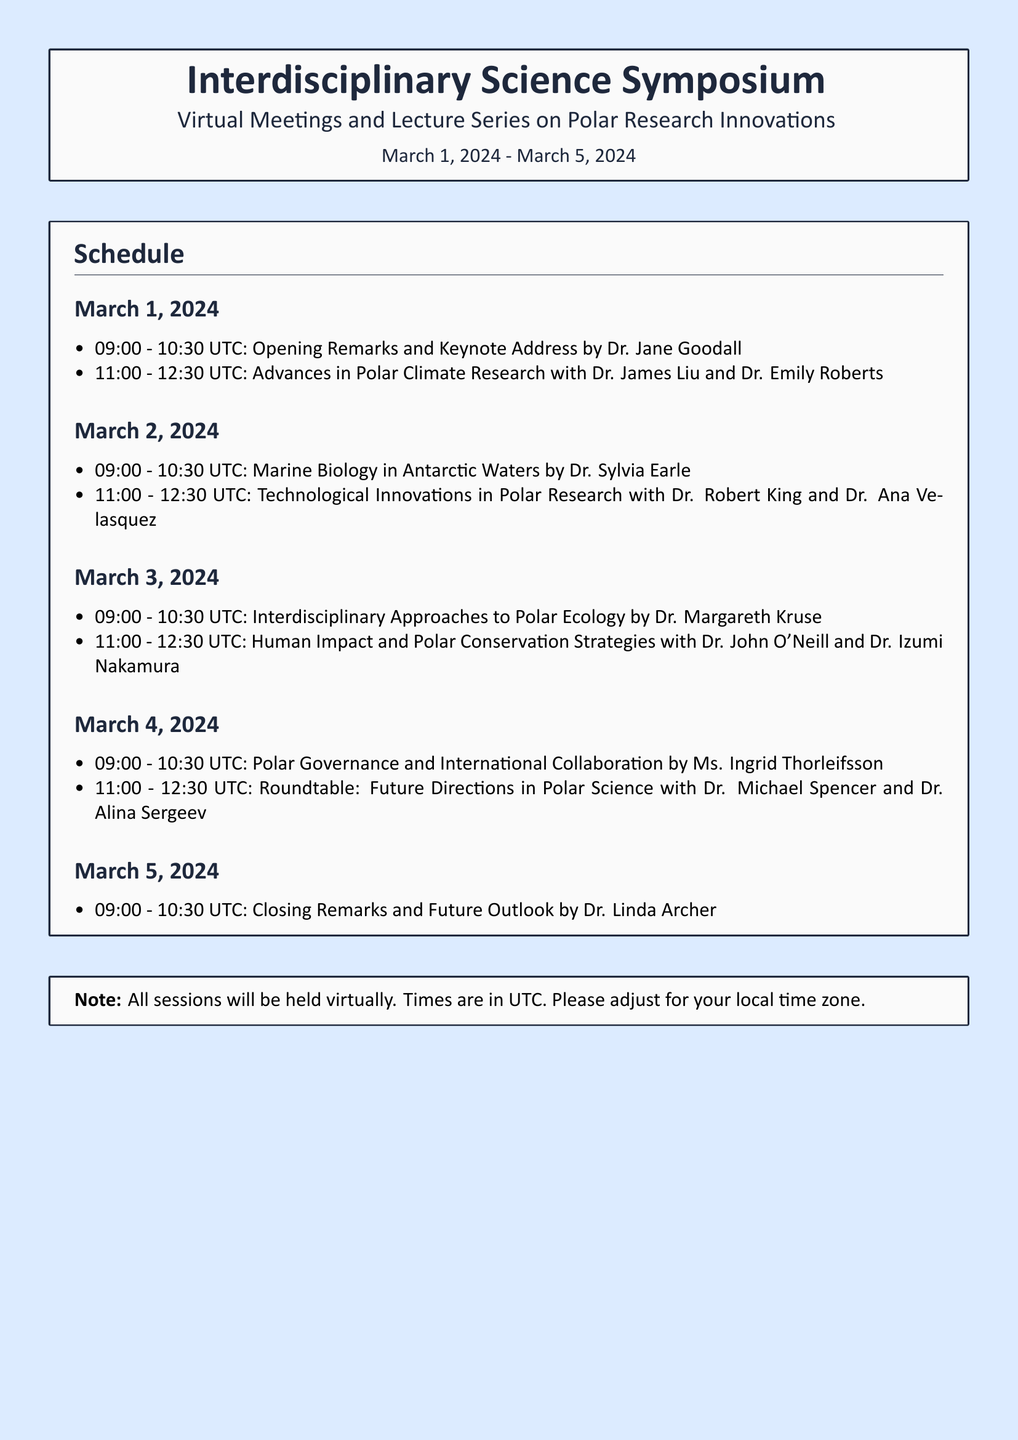What is the date range of the symposium? The date range is specified in the document as March 1, 2024 to March 5, 2024.
Answer: March 1, 2024 - March 5, 2024 Who is giving the keynote address? The keynote address is specified to be given by Dr. Jane Goodall as noted in the schedule.
Answer: Dr. Jane Goodall What time does the session on Marine Biology in Antarctic Waters start? The start time for this session is listed in the schedule as 09:00 UTC on March 2, 2024.
Answer: 09:00 UTC Which day features a roundtable discussion? The roundtable discussion is noted to take place on March 4, 2024.
Answer: March 4, 2024 How many total sessions are listed for March 3, 2024? The total sessions for this day are two, as indicated in the schedule.
Answer: Two sessions Who are the speakers for the session on Human Impact and Polar Conservation Strategies? The speakers for this session are mentioned as Dr. John O'Neill and Dr. Izumi Nakamura in the schedule.
Answer: Dr. John O'Neill and Dr. Izumi Nakamura What is emphasized as important in the note at the end of the document? The note emphasizes that all sessions will be held virtually and mentions adjusting for local time zones.
Answer: All sessions will be held virtually What type of topics are covered during the symposium? The topics covered during the symposium are focused on polar research innovations, as mentioned in the title.
Answer: Polar research innovations 